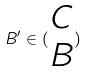Convert formula to latex. <formula><loc_0><loc_0><loc_500><loc_500>B ^ { \prime } \in ( \begin{matrix} C \\ B \end{matrix} )</formula> 